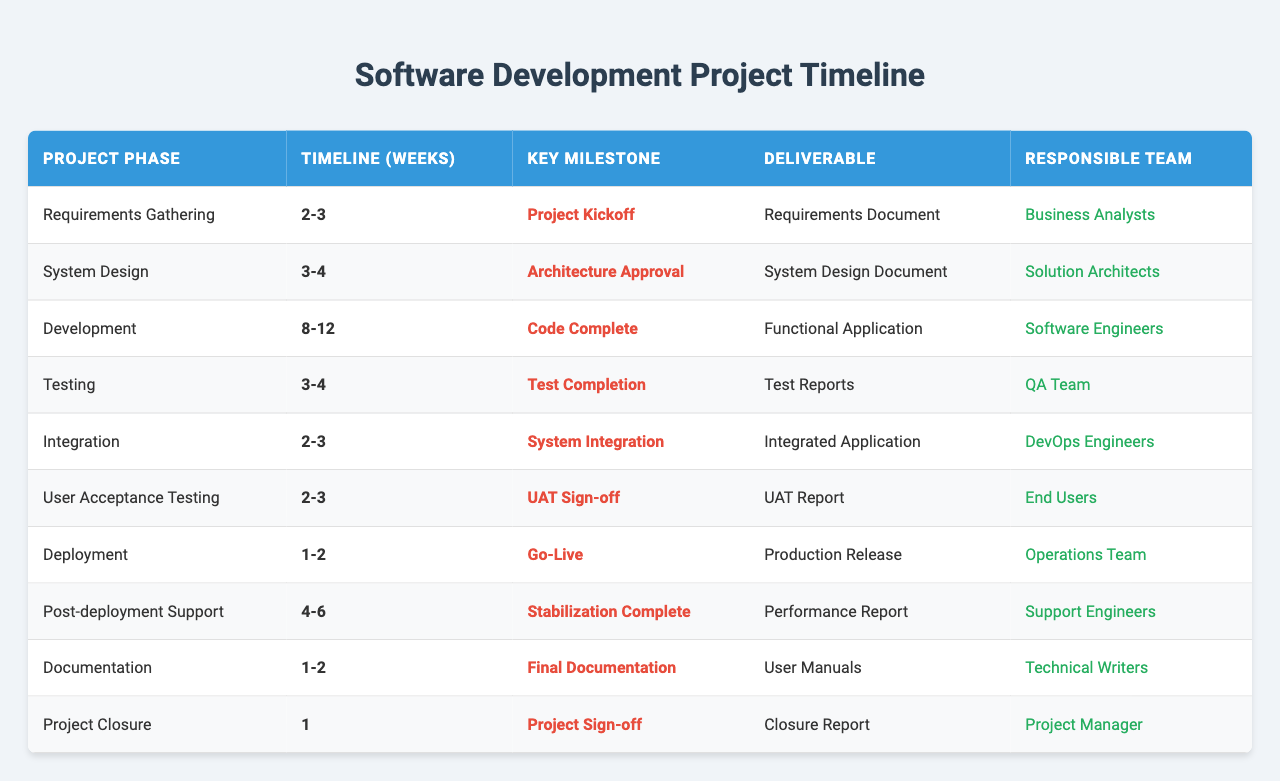What is the timeline for the Development phase? The table shows that the timeline for the Development phase is indicated as "8-12" weeks.
Answer: 8-12 weeks Which team is responsible for Documentation? According to the table, the responsible team for Documentation is the Technical Writers.
Answer: Technical Writers What is the key milestone for the Testing phase? The table lists "Test Completion" as the key milestone for the Testing phase.
Answer: Test Completion Is the User Acceptance Testing phase shorter than the Integration phase? The timeline for User Acceptance Testing is "2-3" weeks, while the Integration phase is also "2-3" weeks; therefore, they are equal in length.
Answer: No What is the duration of the Post-deployment Support phase considered in the table? The Post-deployment Support phase is documented to last "4-6" weeks according to the table.
Answer: 4-6 weeks How many weeks are planned for the Requirements Gathering phase? The table shows that the Requirements Gathering phase is planned for "2-3" weeks.
Answer: 2-3 weeks Which phase has the longest timeline, and what is its duration? By reviewing the table, the Development phase has the longest timeline of "8-12" weeks.
Answer: Development phase; 8-12 weeks If you sum the timelines for the Testing and Integration phases, what is the total duration in weeks? The Testing phase lasts "3-4" weeks, and the Integration phase lasts "2-3" weeks. Adding the lowest ends gives 3 + 2 = 5 weeks and the upper ends give 4 + 3 = 7 weeks. Therefore, the total duration ranges from 5 to 7 weeks.
Answer: 5-7 weeks Is there a phase that involves end users directly, and what is its key milestone? The User Acceptance Testing phase involves end users, with "UAT Sign-off" being its key milestone.
Answer: Yes; UAT Sign-off What is the final milestone before Project Closure according to the table? Reviewing the table, the final milestone before Project Closure is "Project Sign-off".
Answer: Project Sign-off 